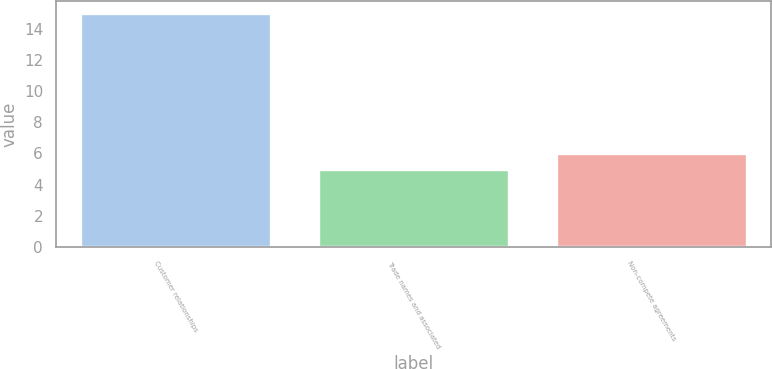<chart> <loc_0><loc_0><loc_500><loc_500><bar_chart><fcel>Customer relationships<fcel>Trade names and associated<fcel>Non-compete agreements<nl><fcel>15<fcel>5<fcel>6<nl></chart> 